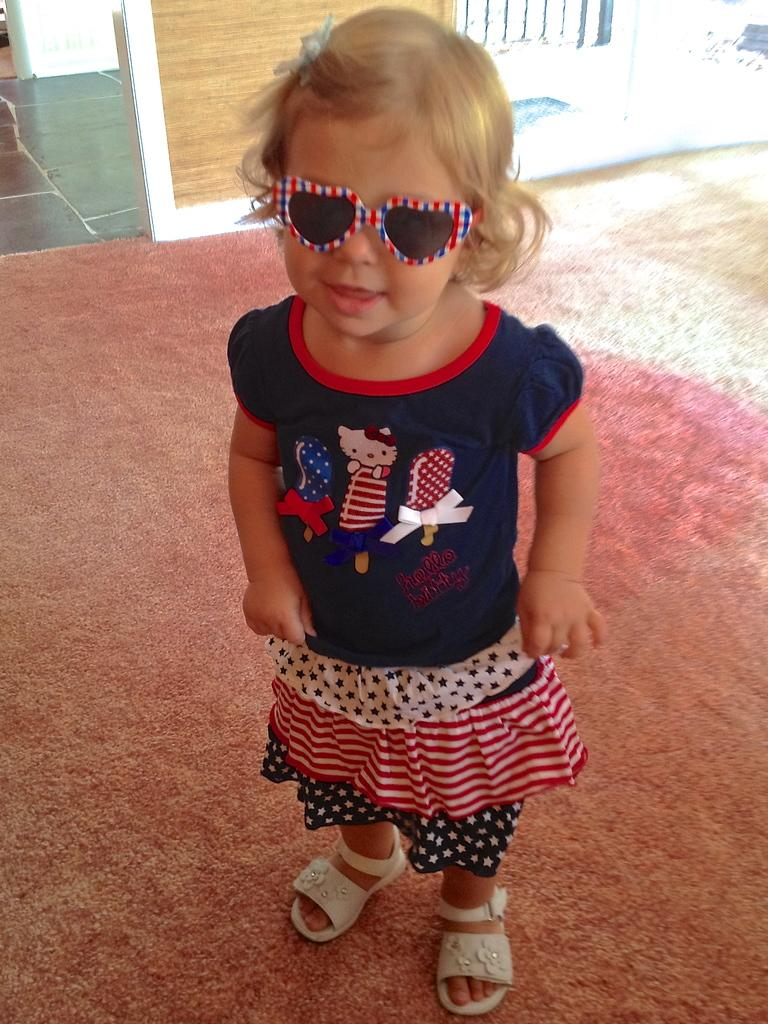Who is the main subject in the foreground of the image? There is a girl in the foreground of the image. What is the girl standing on? The girl is standing on a floor mat. What can be seen in the background of the image? The background of the image includes the floor and a wall. What type of kettle can be seen in the image? There is no kettle present in the image. Is the minister in the image? There is no minister or any religious figure in the image. 